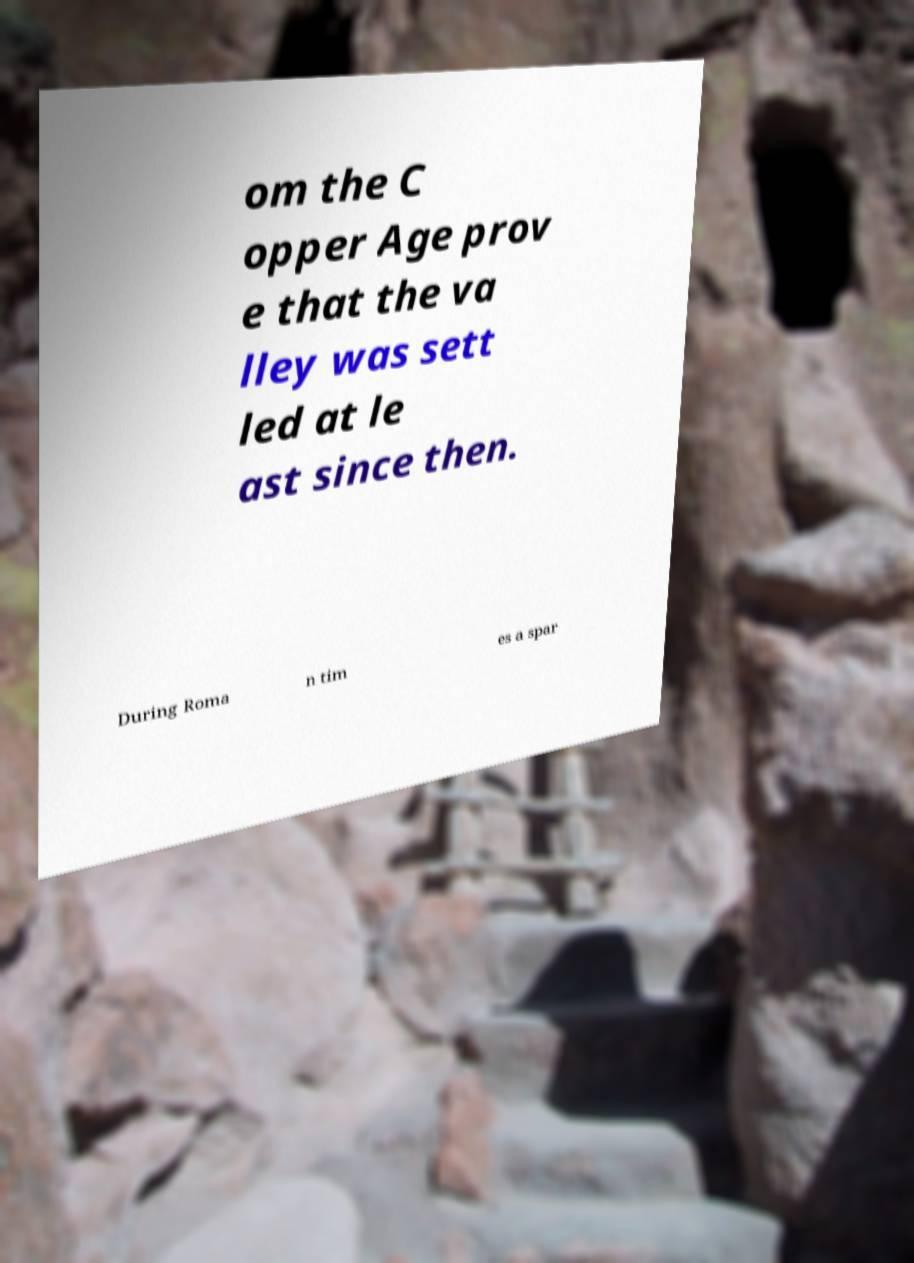There's text embedded in this image that I need extracted. Can you transcribe it verbatim? om the C opper Age prov e that the va lley was sett led at le ast since then. During Roma n tim es a spar 